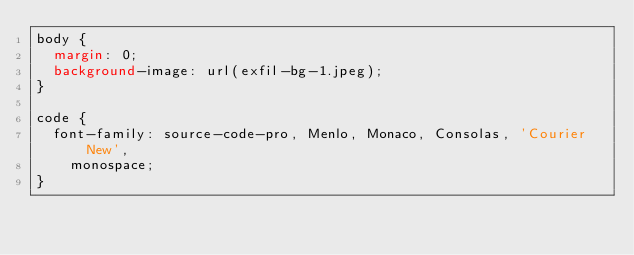Convert code to text. <code><loc_0><loc_0><loc_500><loc_500><_CSS_>body {
  margin: 0;
  background-image: url(exfil-bg-1.jpeg);
}

code {
  font-family: source-code-pro, Menlo, Monaco, Consolas, 'Courier New',
    monospace;
}
</code> 